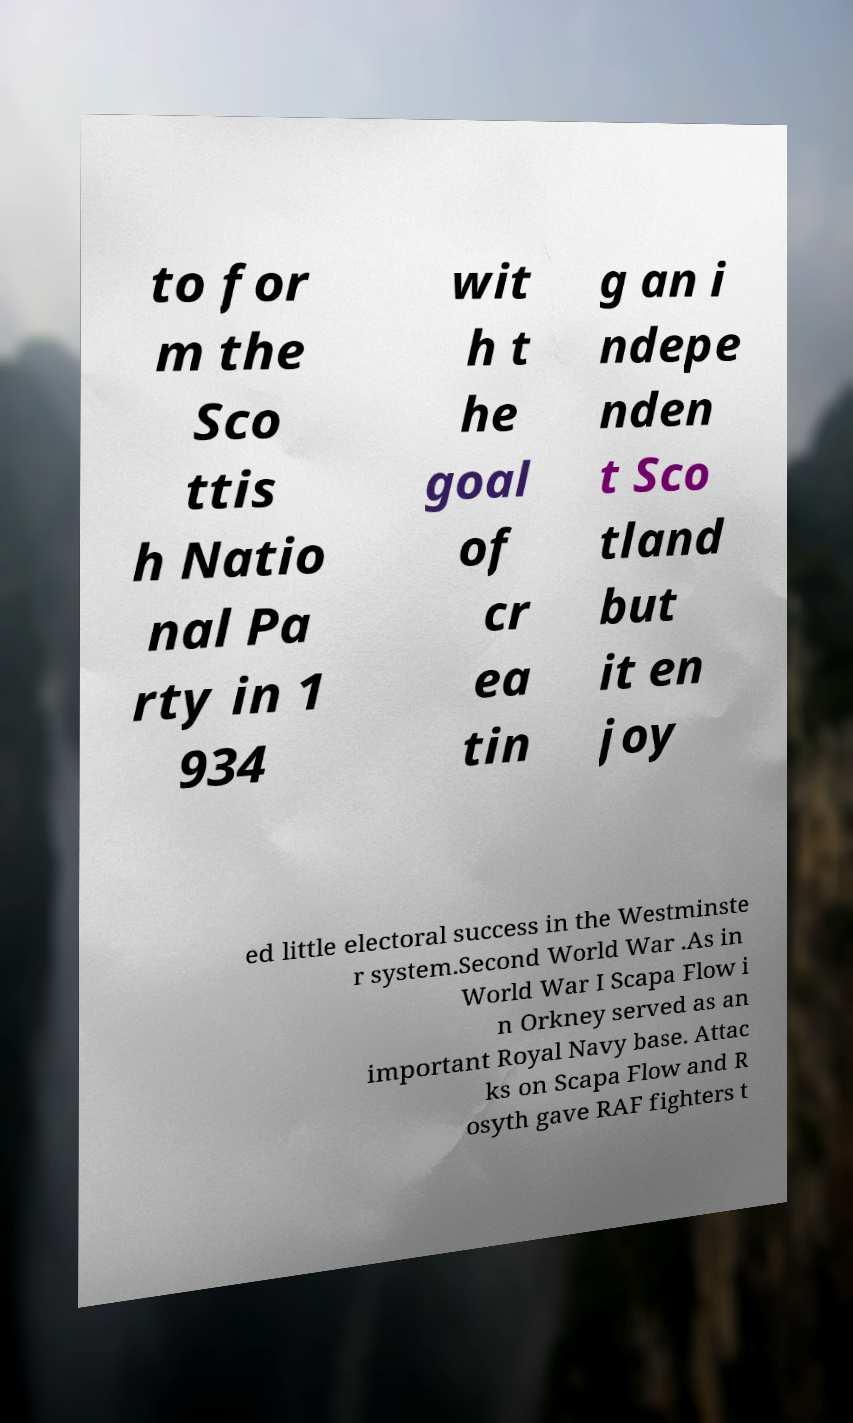What messages or text are displayed in this image? I need them in a readable, typed format. to for m the Sco ttis h Natio nal Pa rty in 1 934 wit h t he goal of cr ea tin g an i ndepe nden t Sco tland but it en joy ed little electoral success in the Westminste r system.Second World War .As in World War I Scapa Flow i n Orkney served as an important Royal Navy base. Attac ks on Scapa Flow and R osyth gave RAF fighters t 